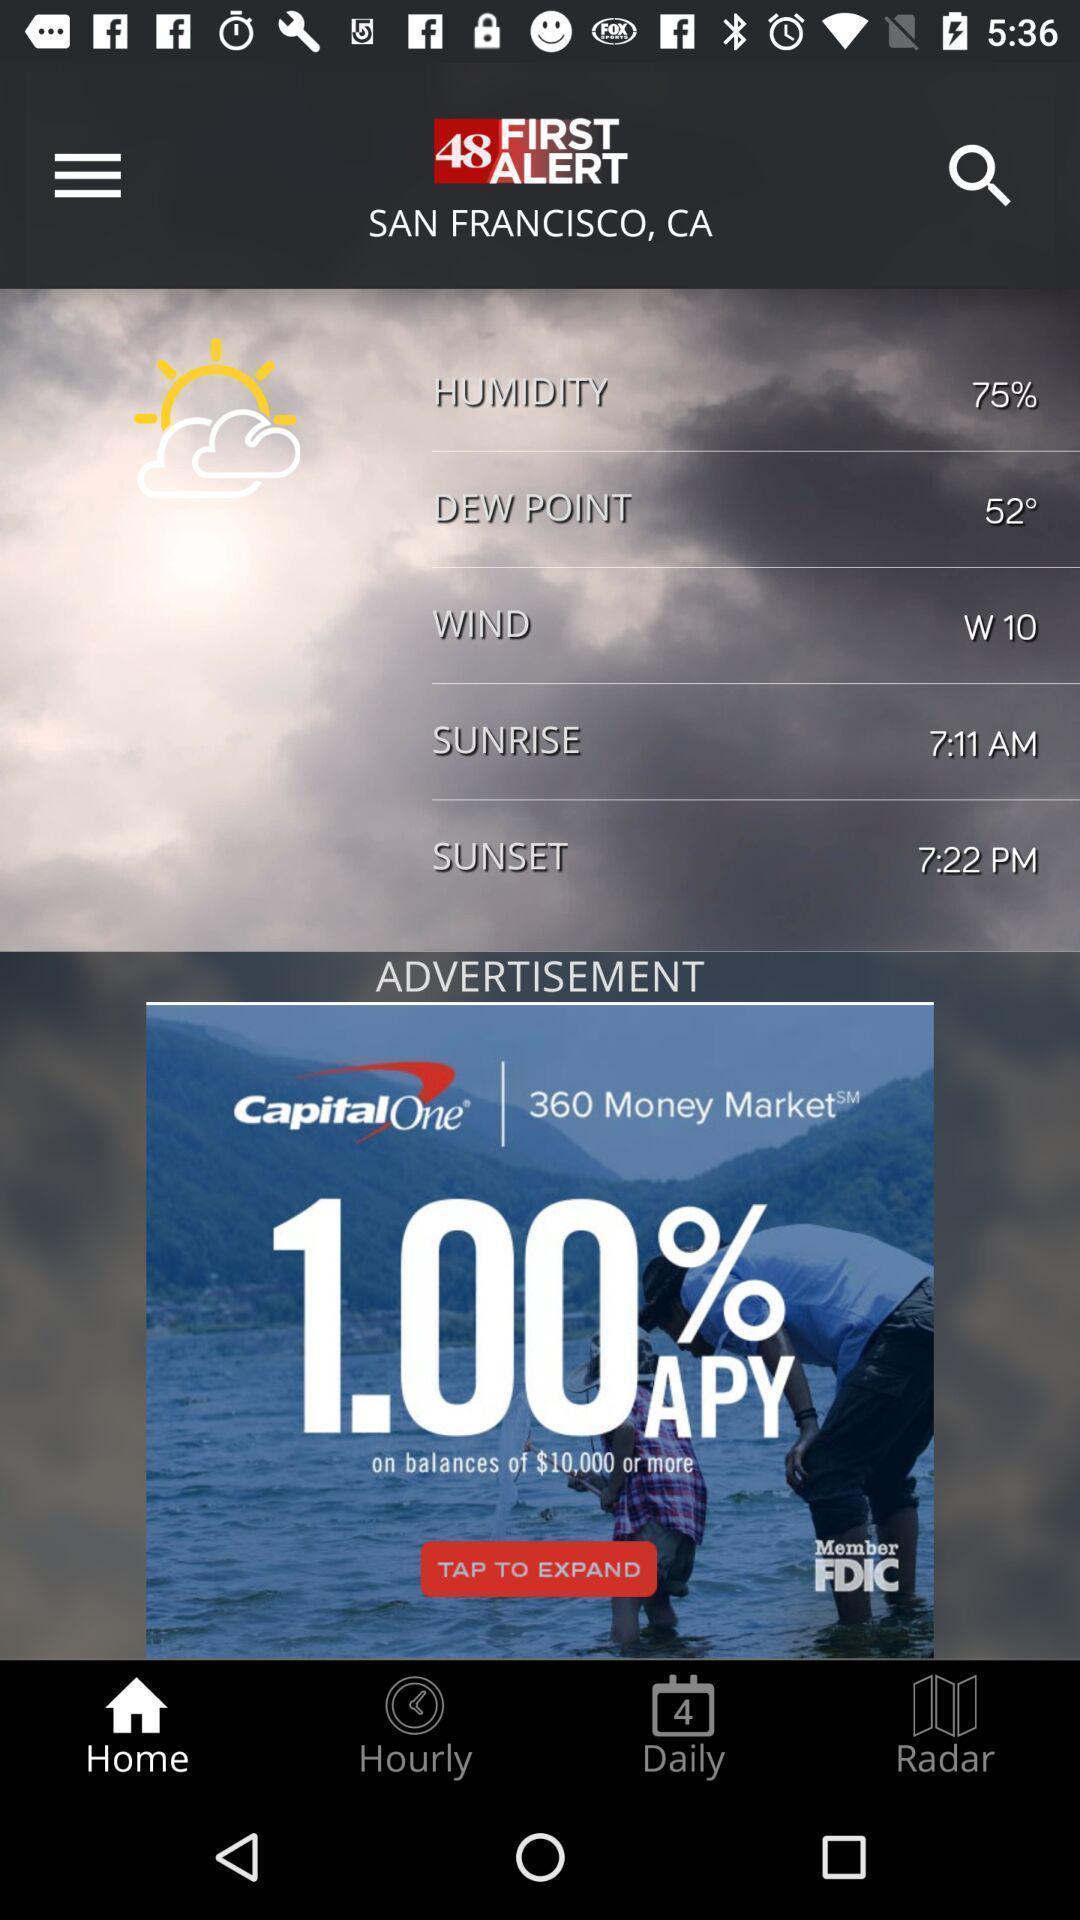Provide a description of this screenshot. San francisco weather information in first alert. 